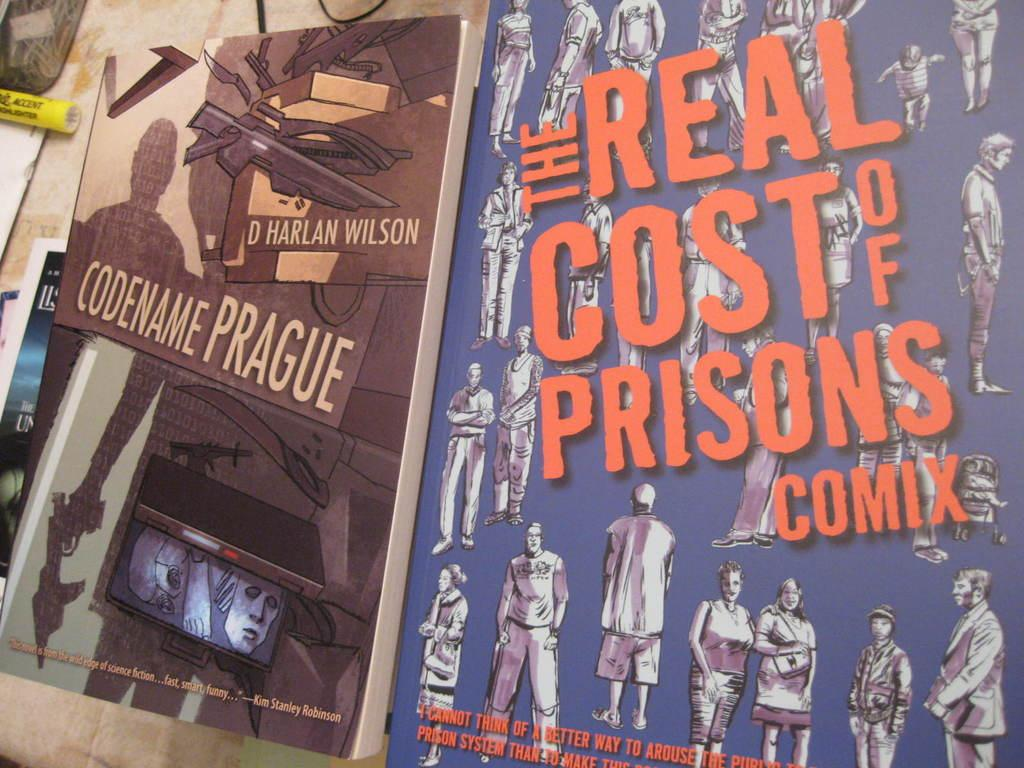<image>
Describe the image concisely. Two comic covers, one called codename prague, the other the real cost of prison comix. 